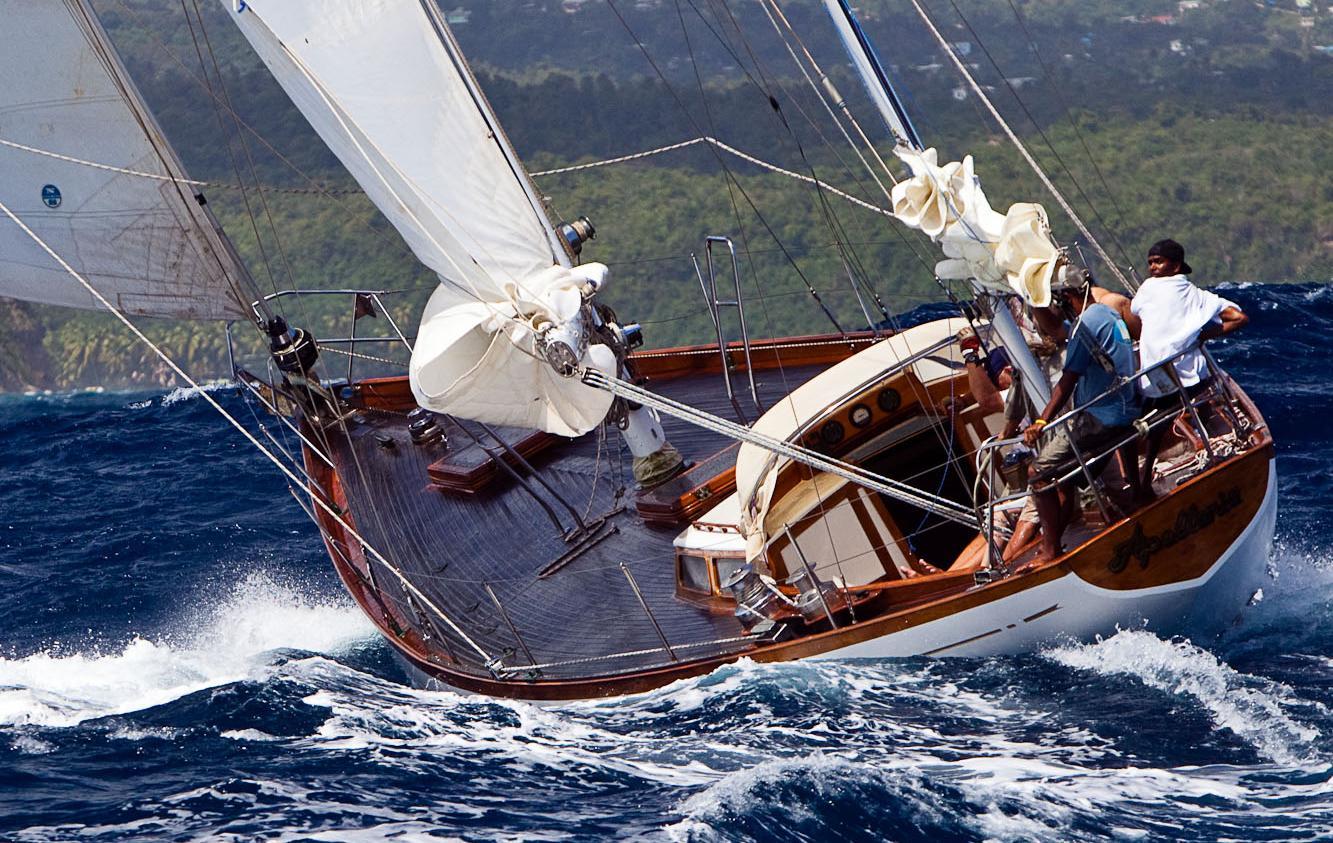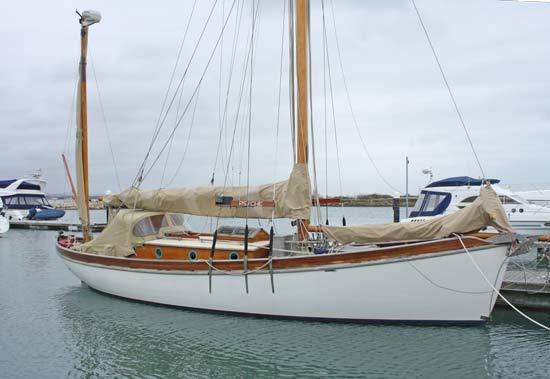The first image is the image on the left, the second image is the image on the right. Analyze the images presented: Is the assertion "There is a sailboat going left with at least two passengers in the boat." valid? Answer yes or no. Yes. The first image is the image on the left, the second image is the image on the right. Analyze the images presented: Is the assertion "The image on the left has a boat with at least three of its sails engaged." valid? Answer yes or no. No. 